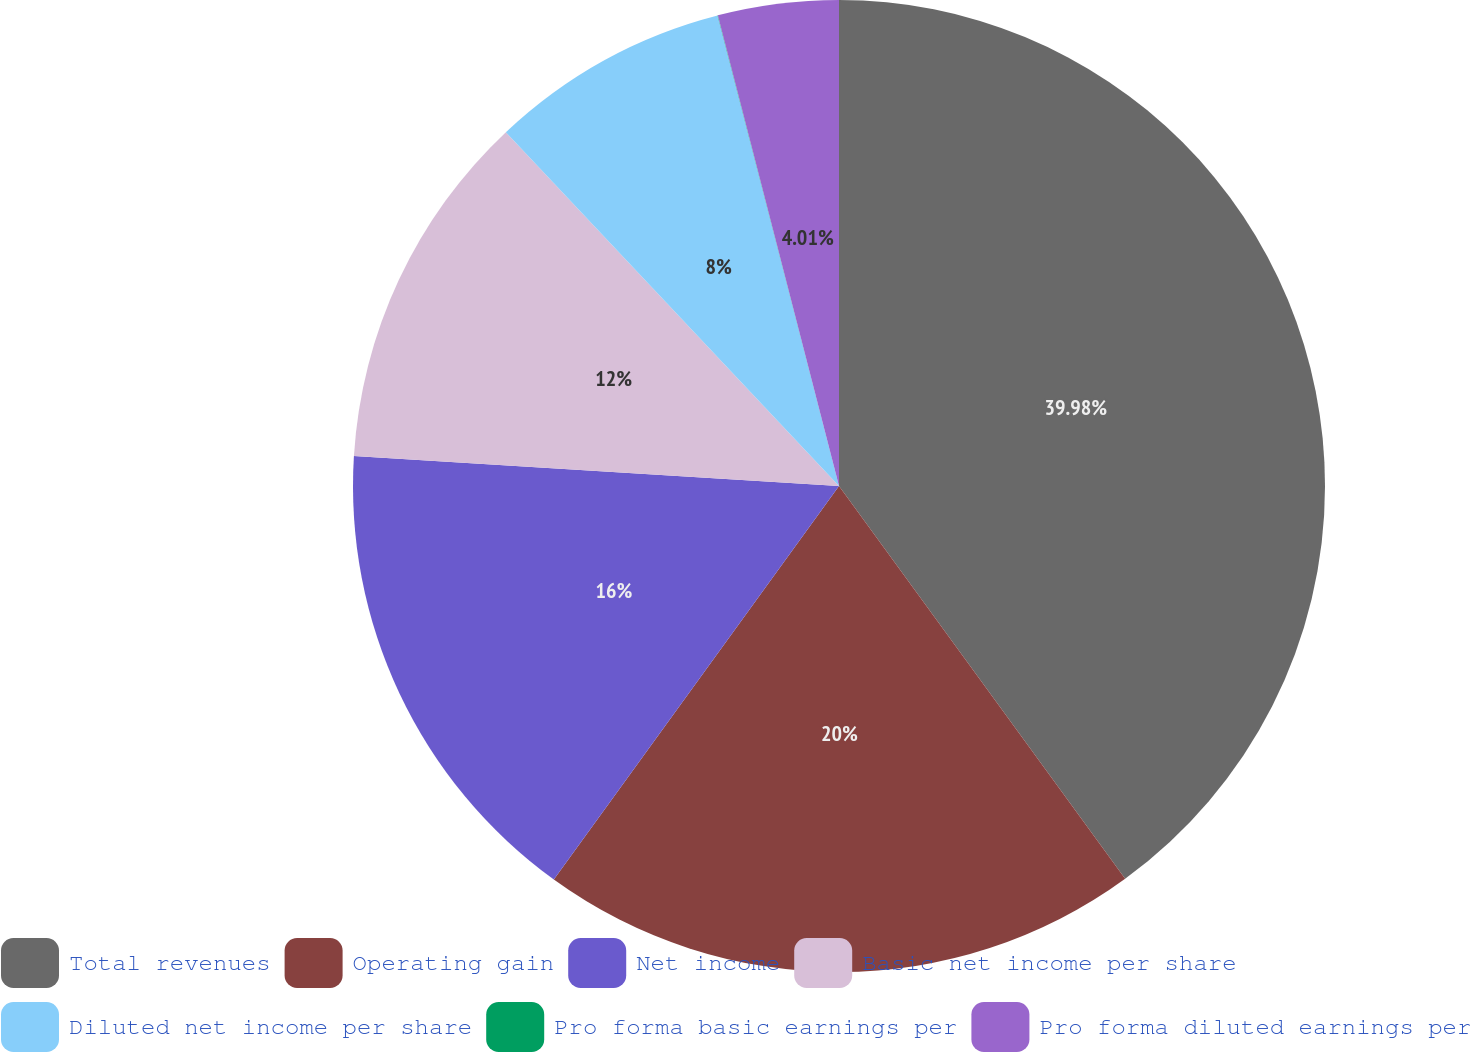Convert chart. <chart><loc_0><loc_0><loc_500><loc_500><pie_chart><fcel>Total revenues<fcel>Operating gain<fcel>Net income<fcel>Basic net income per share<fcel>Diluted net income per share<fcel>Pro forma basic earnings per<fcel>Pro forma diluted earnings per<nl><fcel>39.98%<fcel>20.0%<fcel>16.0%<fcel>12.0%<fcel>8.0%<fcel>0.01%<fcel>4.01%<nl></chart> 